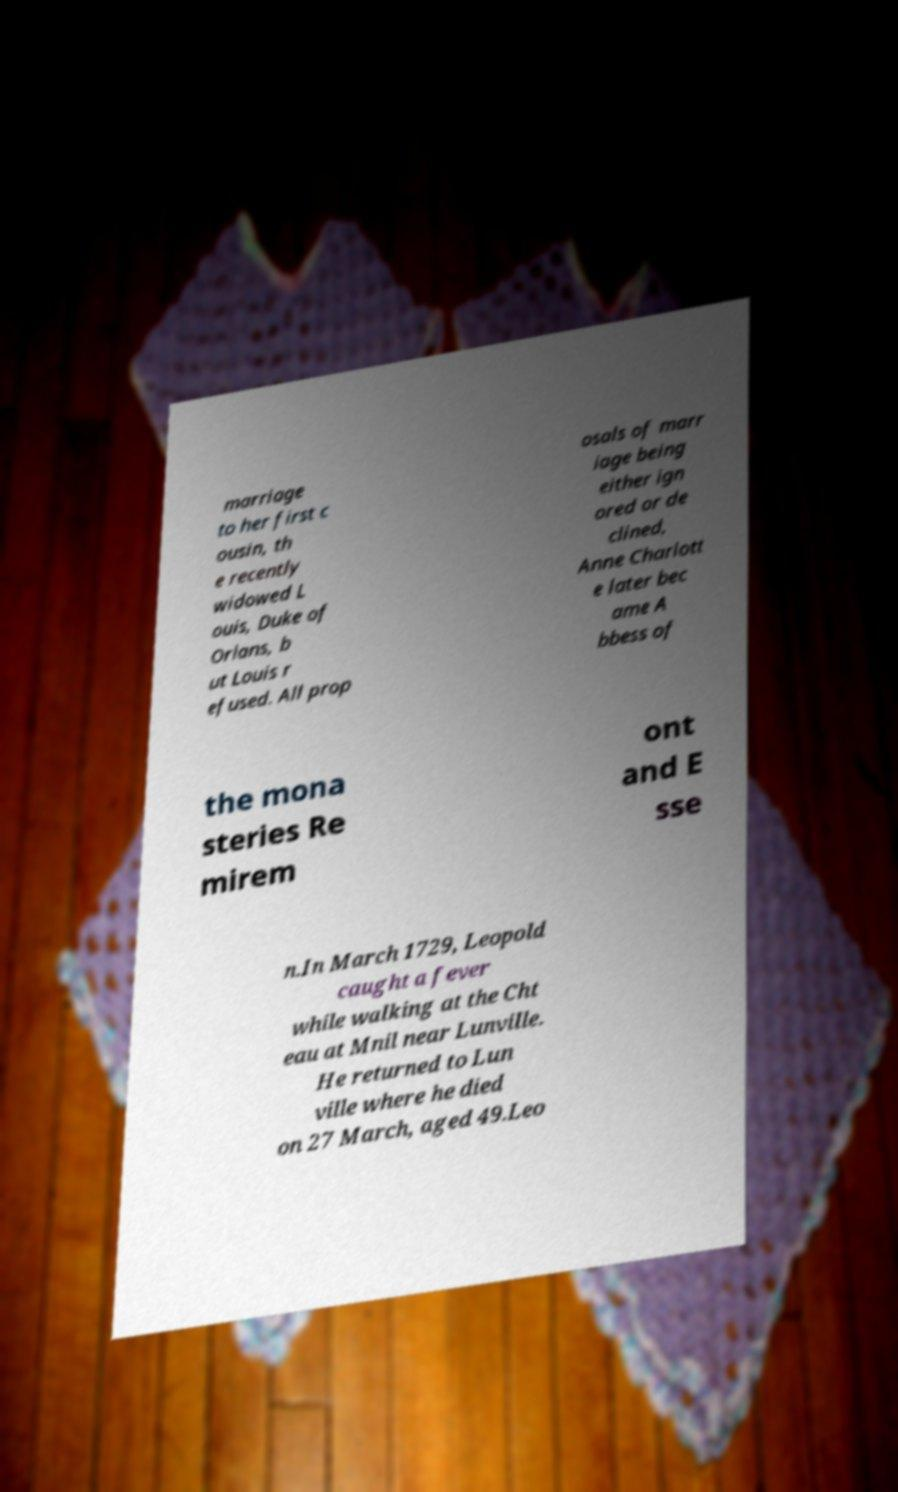Please read and relay the text visible in this image. What does it say? marriage to her first c ousin, th e recently widowed L ouis, Duke of Orlans, b ut Louis r efused. All prop osals of marr iage being either ign ored or de clined, Anne Charlott e later bec ame A bbess of the mona steries Re mirem ont and E sse n.In March 1729, Leopold caught a fever while walking at the Cht eau at Mnil near Lunville. He returned to Lun ville where he died on 27 March, aged 49.Leo 